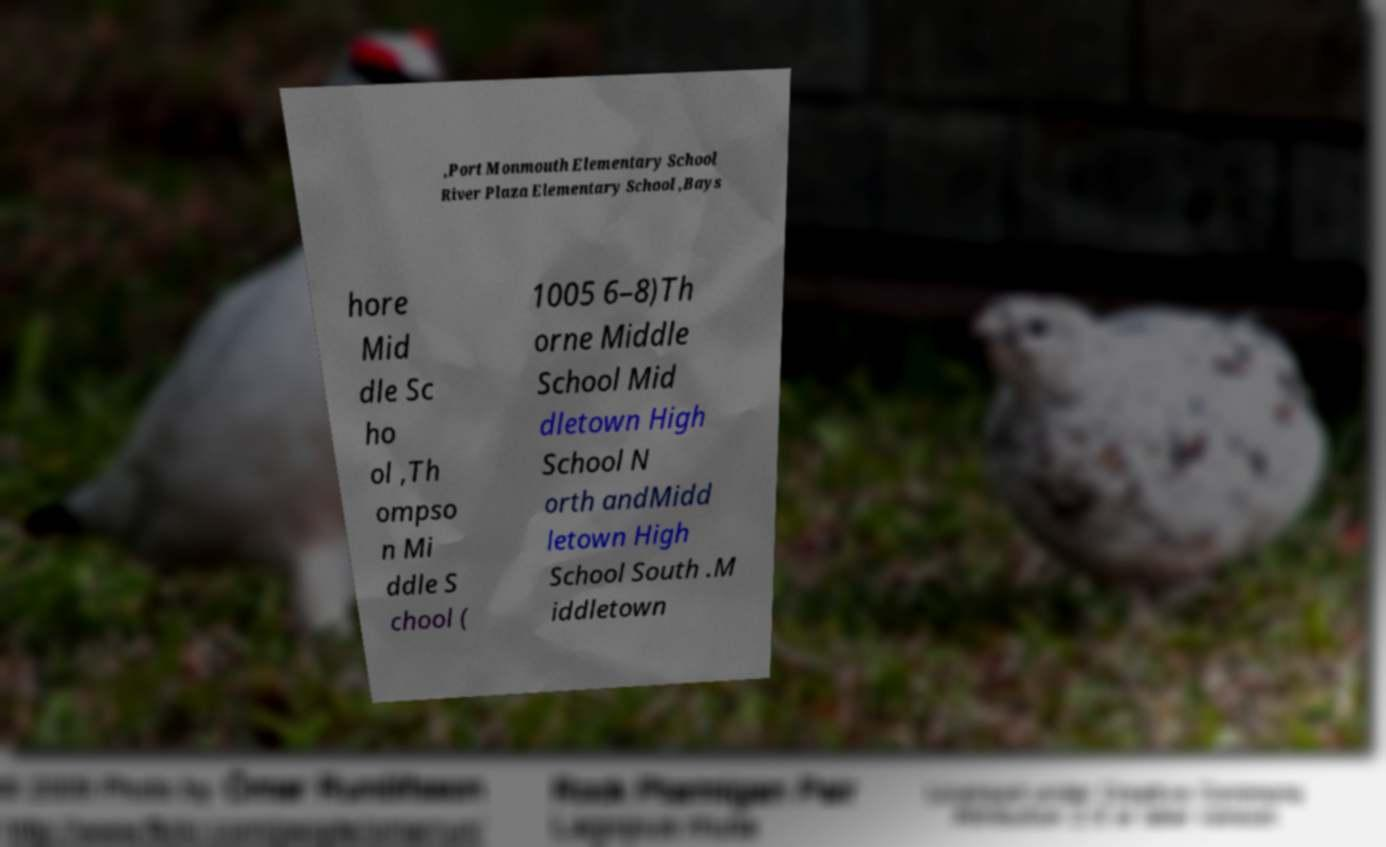Can you accurately transcribe the text from the provided image for me? ,Port Monmouth Elementary School River Plaza Elementary School ,Bays hore Mid dle Sc ho ol ,Th ompso n Mi ddle S chool ( 1005 6–8)Th orne Middle School Mid dletown High School N orth andMidd letown High School South .M iddletown 